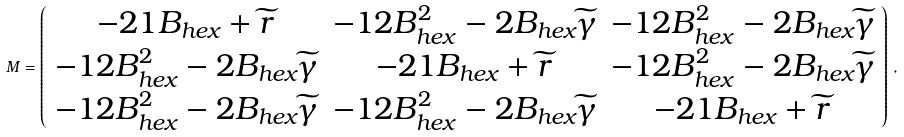Convert formula to latex. <formula><loc_0><loc_0><loc_500><loc_500>M = \left ( \begin{array} { c c c } - 2 1 B _ { h e x } + \widetilde { r } & - 1 2 B _ { h e x } ^ { 2 } - 2 B _ { h e x } \widetilde { \gamma } & - 1 2 B _ { h e x } ^ { 2 } - 2 B _ { h e x } \widetilde { \gamma } \\ - 1 2 B _ { h e x } ^ { 2 } - 2 B _ { h e x } \widetilde { \gamma } & - 2 1 B _ { h e x } + \widetilde { r } & - 1 2 B _ { h e x } ^ { 2 } - 2 B _ { h e x } \widetilde { \gamma } \\ - 1 2 B _ { h e x } ^ { 2 } - 2 B _ { h e x } \widetilde { \gamma } & - 1 2 B _ { h e x } ^ { 2 } - 2 B _ { h e x } \widetilde { \gamma } & - 2 1 B _ { h e x } + \widetilde { r } \end{array} \right ) \, ,</formula> 